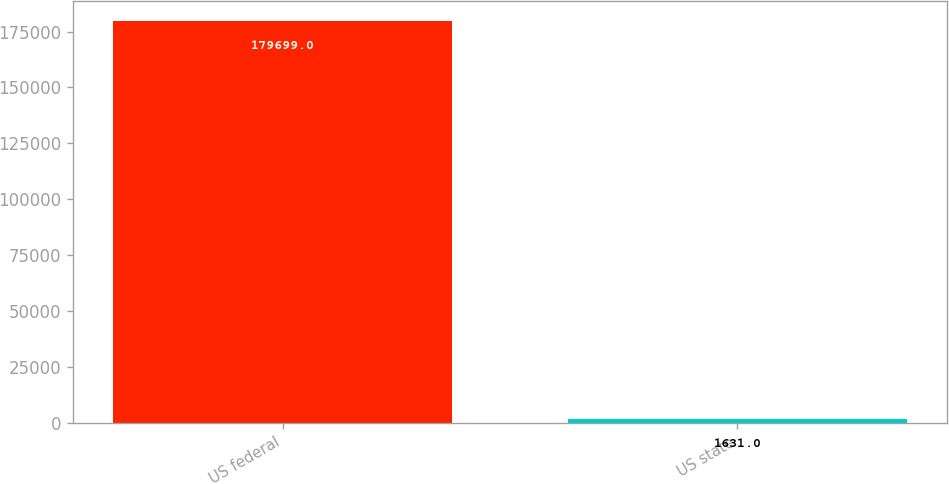Convert chart. <chart><loc_0><loc_0><loc_500><loc_500><bar_chart><fcel>US federal<fcel>US state<nl><fcel>179699<fcel>1631<nl></chart> 